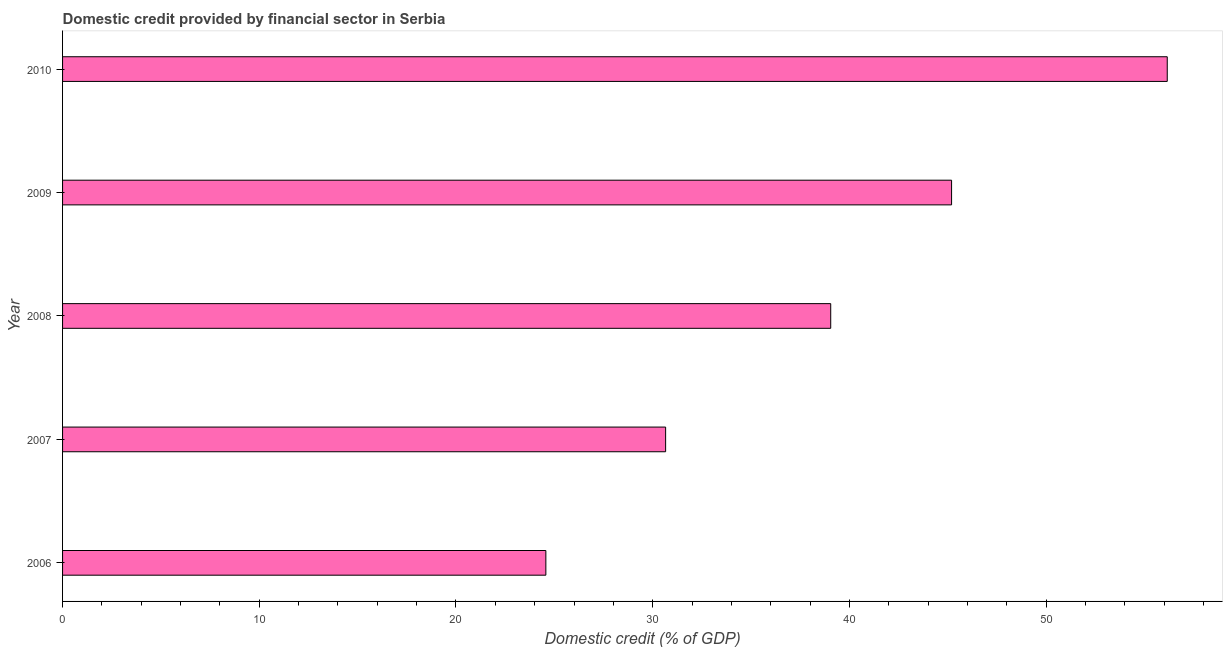Does the graph contain grids?
Ensure brevity in your answer.  No. What is the title of the graph?
Your response must be concise. Domestic credit provided by financial sector in Serbia. What is the label or title of the X-axis?
Provide a short and direct response. Domestic credit (% of GDP). What is the domestic credit provided by financial sector in 2007?
Make the answer very short. 30.66. Across all years, what is the maximum domestic credit provided by financial sector?
Your response must be concise. 56.16. Across all years, what is the minimum domestic credit provided by financial sector?
Your response must be concise. 24.57. In which year was the domestic credit provided by financial sector maximum?
Your answer should be very brief. 2010. What is the sum of the domestic credit provided by financial sector?
Make the answer very short. 195.63. What is the difference between the domestic credit provided by financial sector in 2008 and 2009?
Offer a very short reply. -6.14. What is the average domestic credit provided by financial sector per year?
Keep it short and to the point. 39.13. What is the median domestic credit provided by financial sector?
Your answer should be very brief. 39.05. What is the ratio of the domestic credit provided by financial sector in 2006 to that in 2010?
Keep it short and to the point. 0.44. Is the domestic credit provided by financial sector in 2006 less than that in 2008?
Ensure brevity in your answer.  Yes. Is the difference between the domestic credit provided by financial sector in 2007 and 2010 greater than the difference between any two years?
Provide a succinct answer. No. What is the difference between the highest and the second highest domestic credit provided by financial sector?
Offer a terse response. 10.96. What is the difference between the highest and the lowest domestic credit provided by financial sector?
Provide a succinct answer. 31.59. Are all the bars in the graph horizontal?
Provide a short and direct response. Yes. How many years are there in the graph?
Offer a terse response. 5. What is the difference between two consecutive major ticks on the X-axis?
Your answer should be compact. 10. What is the Domestic credit (% of GDP) in 2006?
Ensure brevity in your answer.  24.57. What is the Domestic credit (% of GDP) in 2007?
Provide a succinct answer. 30.66. What is the Domestic credit (% of GDP) in 2008?
Give a very brief answer. 39.05. What is the Domestic credit (% of GDP) of 2009?
Give a very brief answer. 45.2. What is the Domestic credit (% of GDP) of 2010?
Give a very brief answer. 56.16. What is the difference between the Domestic credit (% of GDP) in 2006 and 2007?
Give a very brief answer. -6.09. What is the difference between the Domestic credit (% of GDP) in 2006 and 2008?
Ensure brevity in your answer.  -14.48. What is the difference between the Domestic credit (% of GDP) in 2006 and 2009?
Make the answer very short. -20.63. What is the difference between the Domestic credit (% of GDP) in 2006 and 2010?
Provide a short and direct response. -31.59. What is the difference between the Domestic credit (% of GDP) in 2007 and 2008?
Make the answer very short. -8.39. What is the difference between the Domestic credit (% of GDP) in 2007 and 2009?
Provide a short and direct response. -14.54. What is the difference between the Domestic credit (% of GDP) in 2007 and 2010?
Your response must be concise. -25.5. What is the difference between the Domestic credit (% of GDP) in 2008 and 2009?
Provide a succinct answer. -6.14. What is the difference between the Domestic credit (% of GDP) in 2008 and 2010?
Give a very brief answer. -17.11. What is the difference between the Domestic credit (% of GDP) in 2009 and 2010?
Offer a very short reply. -10.96. What is the ratio of the Domestic credit (% of GDP) in 2006 to that in 2007?
Your answer should be compact. 0.8. What is the ratio of the Domestic credit (% of GDP) in 2006 to that in 2008?
Your answer should be compact. 0.63. What is the ratio of the Domestic credit (% of GDP) in 2006 to that in 2009?
Offer a very short reply. 0.54. What is the ratio of the Domestic credit (% of GDP) in 2006 to that in 2010?
Give a very brief answer. 0.44. What is the ratio of the Domestic credit (% of GDP) in 2007 to that in 2008?
Provide a succinct answer. 0.79. What is the ratio of the Domestic credit (% of GDP) in 2007 to that in 2009?
Give a very brief answer. 0.68. What is the ratio of the Domestic credit (% of GDP) in 2007 to that in 2010?
Your answer should be compact. 0.55. What is the ratio of the Domestic credit (% of GDP) in 2008 to that in 2009?
Make the answer very short. 0.86. What is the ratio of the Domestic credit (% of GDP) in 2008 to that in 2010?
Keep it short and to the point. 0.69. What is the ratio of the Domestic credit (% of GDP) in 2009 to that in 2010?
Ensure brevity in your answer.  0.81. 